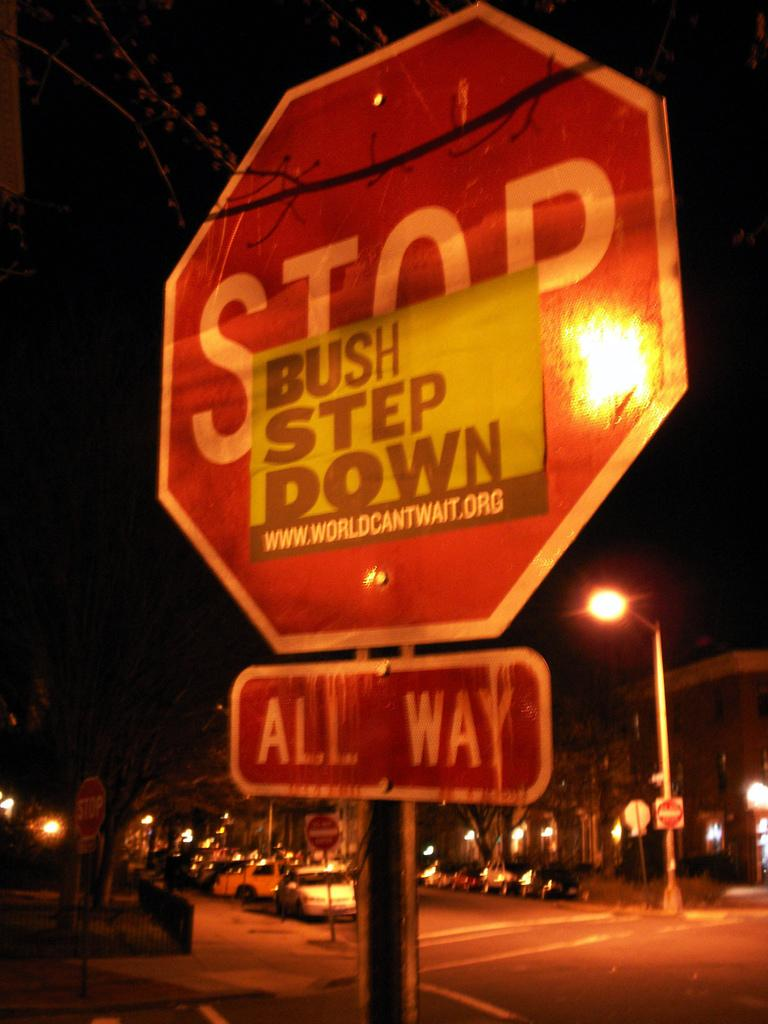<image>
Provide a brief description of the given image. A stop sign with a sign that says bush step down pasted on it. 